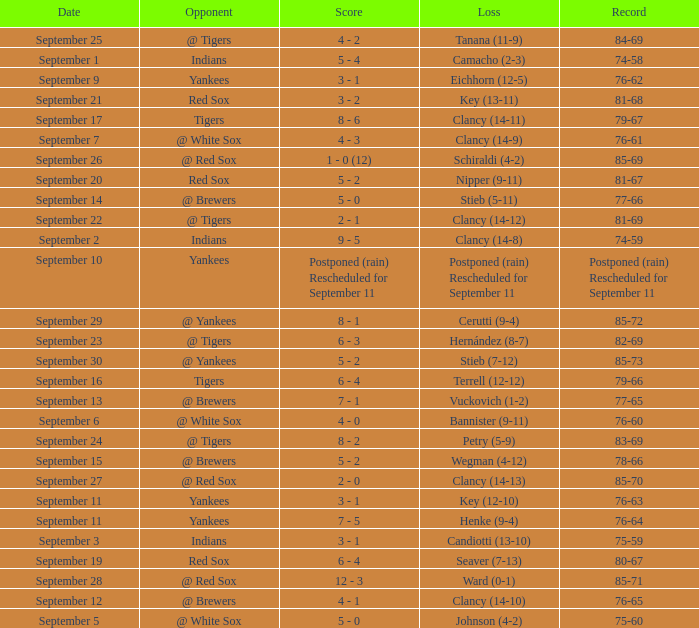What was the date of the game when their record was 84-69? September 25. Give me the full table as a dictionary. {'header': ['Date', 'Opponent', 'Score', 'Loss', 'Record'], 'rows': [['September 25', '@ Tigers', '4 - 2', 'Tanana (11-9)', '84-69'], ['September 1', 'Indians', '5 - 4', 'Camacho (2-3)', '74-58'], ['September 9', 'Yankees', '3 - 1', 'Eichhorn (12-5)', '76-62'], ['September 21', 'Red Sox', '3 - 2', 'Key (13-11)', '81-68'], ['September 17', 'Tigers', '8 - 6', 'Clancy (14-11)', '79-67'], ['September 7', '@ White Sox', '4 - 3', 'Clancy (14-9)', '76-61'], ['September 26', '@ Red Sox', '1 - 0 (12)', 'Schiraldi (4-2)', '85-69'], ['September 20', 'Red Sox', '5 - 2', 'Nipper (9-11)', '81-67'], ['September 14', '@ Brewers', '5 - 0', 'Stieb (5-11)', '77-66'], ['September 22', '@ Tigers', '2 - 1', 'Clancy (14-12)', '81-69'], ['September 2', 'Indians', '9 - 5', 'Clancy (14-8)', '74-59'], ['September 10', 'Yankees', 'Postponed (rain) Rescheduled for September 11', 'Postponed (rain) Rescheduled for September 11', 'Postponed (rain) Rescheduled for September 11'], ['September 29', '@ Yankees', '8 - 1', 'Cerutti (9-4)', '85-72'], ['September 23', '@ Tigers', '6 - 3', 'Hernández (8-7)', '82-69'], ['September 30', '@ Yankees', '5 - 2', 'Stieb (7-12)', '85-73'], ['September 16', 'Tigers', '6 - 4', 'Terrell (12-12)', '79-66'], ['September 13', '@ Brewers', '7 - 1', 'Vuckovich (1-2)', '77-65'], ['September 6', '@ White Sox', '4 - 0', 'Bannister (9-11)', '76-60'], ['September 24', '@ Tigers', '8 - 2', 'Petry (5-9)', '83-69'], ['September 15', '@ Brewers', '5 - 2', 'Wegman (4-12)', '78-66'], ['September 27', '@ Red Sox', '2 - 0', 'Clancy (14-13)', '85-70'], ['September 11', 'Yankees', '3 - 1', 'Key (12-10)', '76-63'], ['September 11', 'Yankees', '7 - 5', 'Henke (9-4)', '76-64'], ['September 3', 'Indians', '3 - 1', 'Candiotti (13-10)', '75-59'], ['September 19', 'Red Sox', '6 - 4', 'Seaver (7-13)', '80-67'], ['September 28', '@ Red Sox', '12 - 3', 'Ward (0-1)', '85-71'], ['September 12', '@ Brewers', '4 - 1', 'Clancy (14-10)', '76-65'], ['September 5', '@ White Sox', '5 - 0', 'Johnson (4-2)', '75-60']]} 